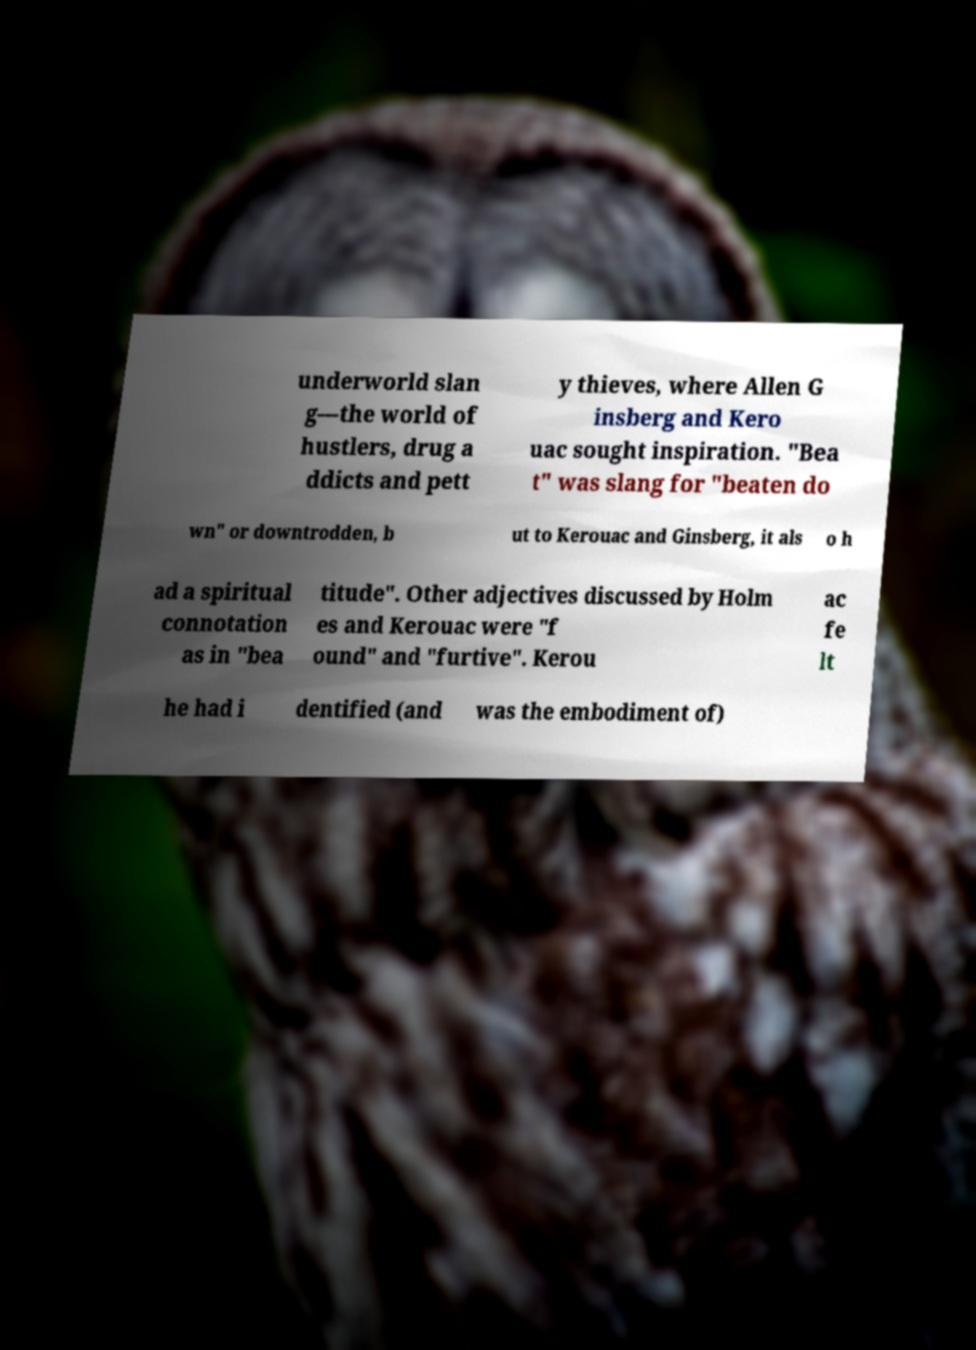Could you extract and type out the text from this image? underworld slan g—the world of hustlers, drug a ddicts and pett y thieves, where Allen G insberg and Kero uac sought inspiration. "Bea t" was slang for "beaten do wn" or downtrodden, b ut to Kerouac and Ginsberg, it als o h ad a spiritual connotation as in "bea titude". Other adjectives discussed by Holm es and Kerouac were "f ound" and "furtive". Kerou ac fe lt he had i dentified (and was the embodiment of) 